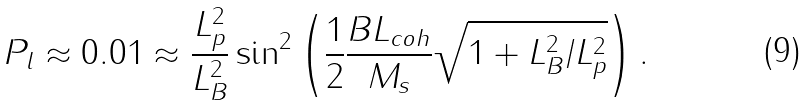Convert formula to latex. <formula><loc_0><loc_0><loc_500><loc_500>P _ { l } \approx 0 . 0 1 \approx \frac { L _ { p } ^ { 2 } } { L _ { B } ^ { 2 } } \sin ^ { 2 } \left ( \frac { 1 } { 2 } \frac { B L _ { c o h } } { M _ { s } } \sqrt { 1 + L _ { B } ^ { 2 } / L _ { p } ^ { 2 } } \right ) .</formula> 